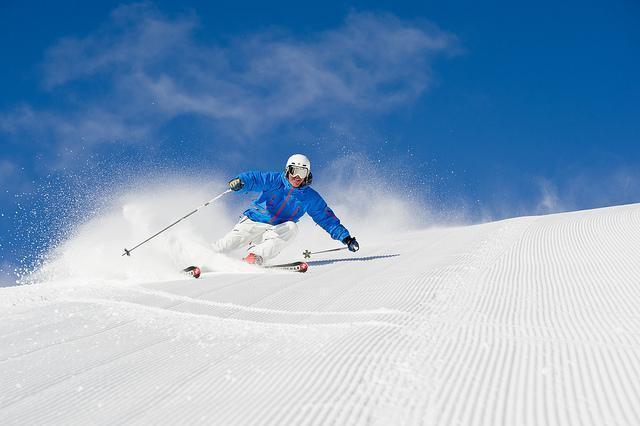How many skies are off the ground?
Give a very brief answer. 0. How many people can you see?
Give a very brief answer. 1. 